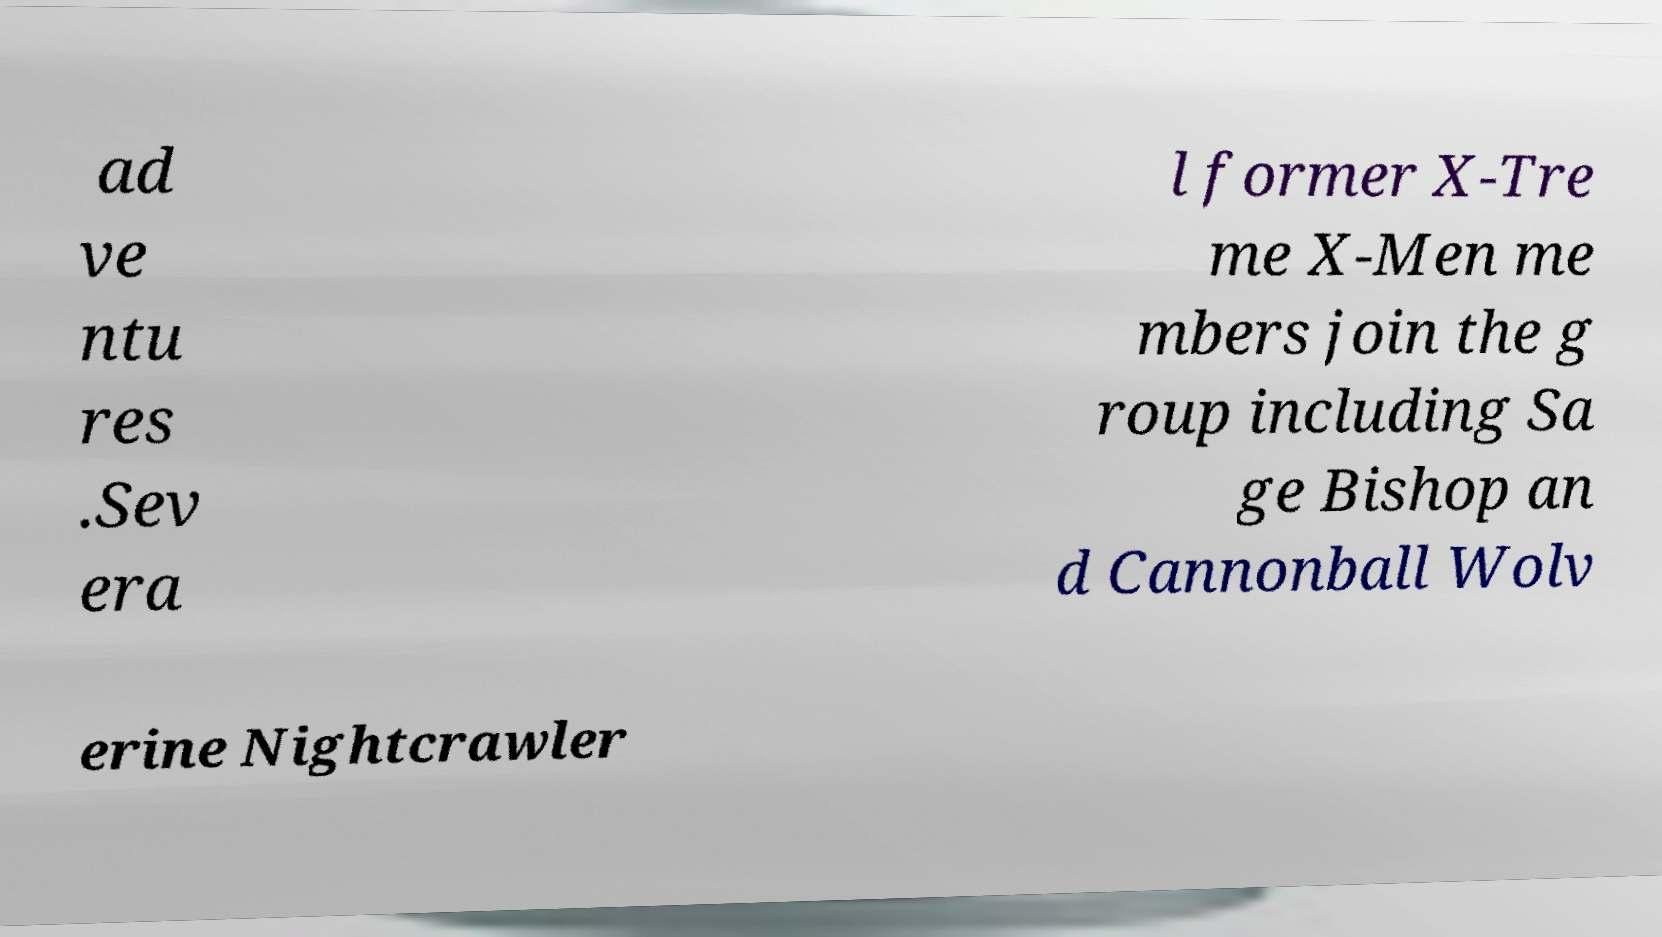I need the written content from this picture converted into text. Can you do that? ad ve ntu res .Sev era l former X-Tre me X-Men me mbers join the g roup including Sa ge Bishop an d Cannonball Wolv erine Nightcrawler 